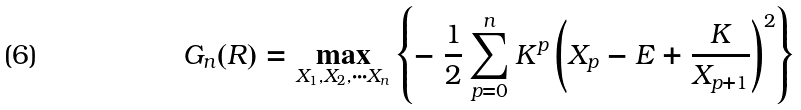Convert formula to latex. <formula><loc_0><loc_0><loc_500><loc_500>G _ { n } ( R ) = \max _ { X _ { 1 } , X _ { 2 } , \cdots X _ { n } } \left \{ - \ \frac { 1 } { 2 } \sum _ { p = 0 } ^ { n } K ^ { p } \left ( X _ { p } - E + \frac { K } { X _ { p + 1 } } \right ) ^ { 2 } \right \}</formula> 